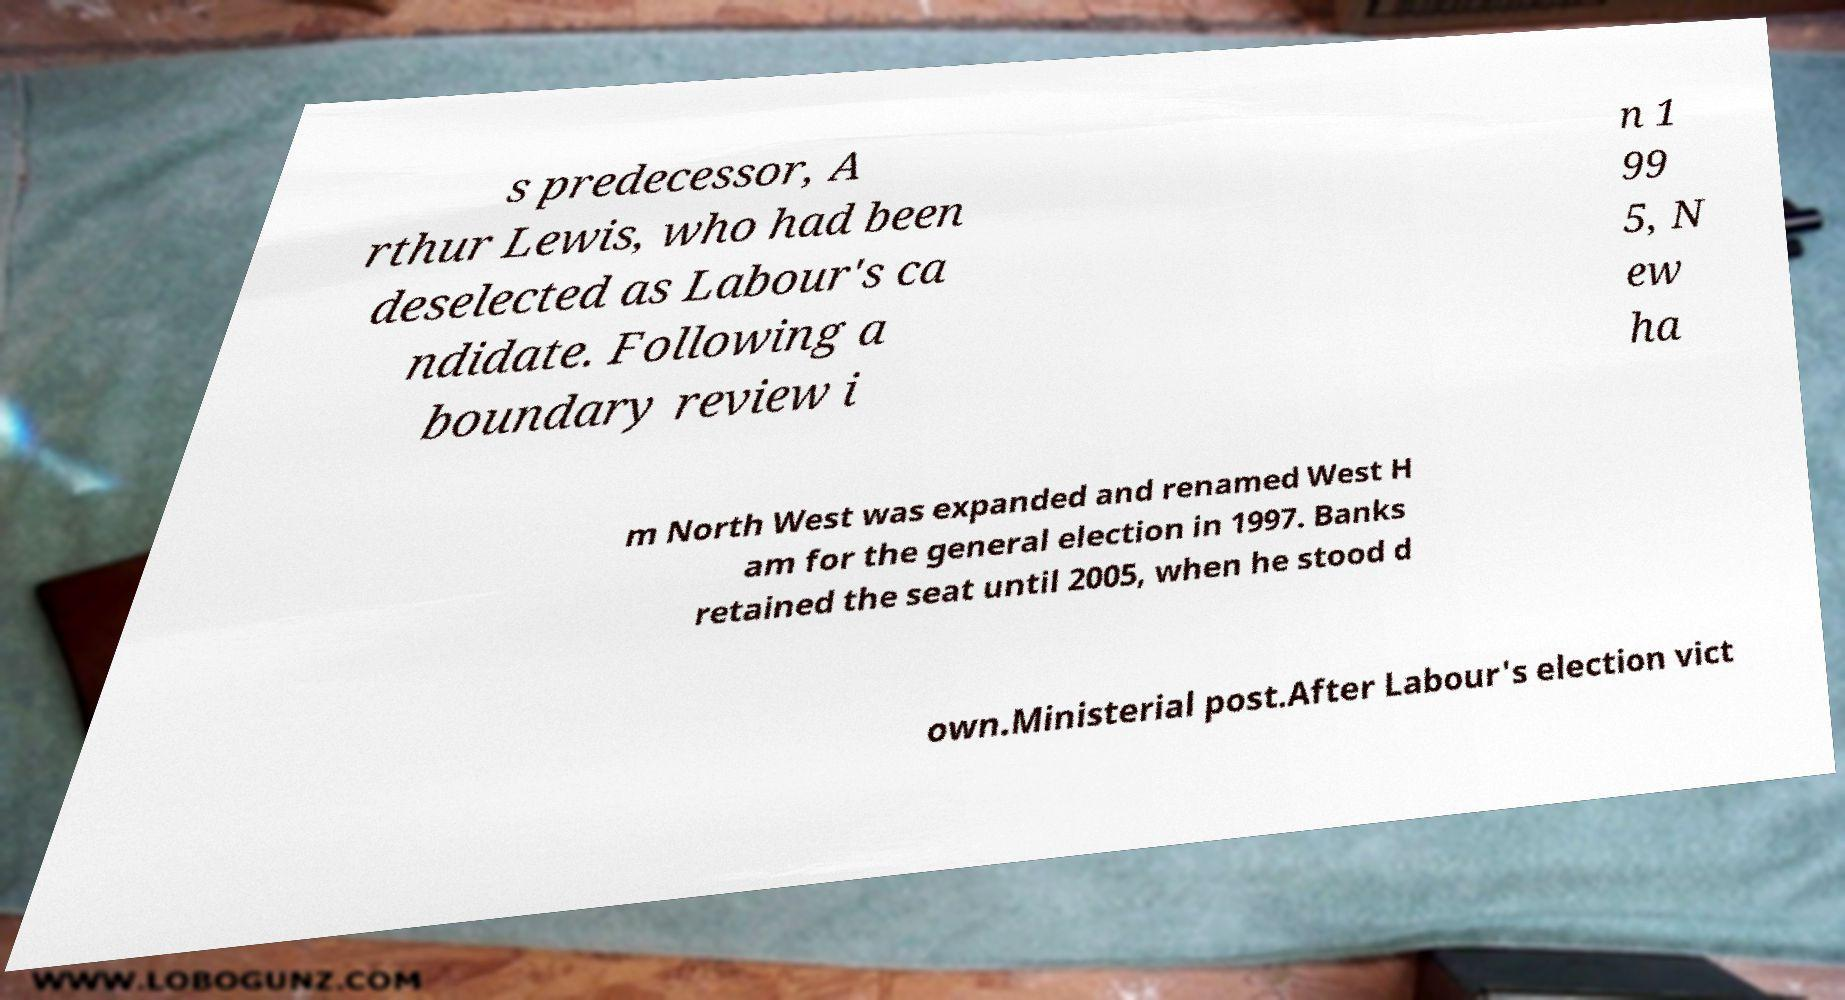I need the written content from this picture converted into text. Can you do that? s predecessor, A rthur Lewis, who had been deselected as Labour's ca ndidate. Following a boundary review i n 1 99 5, N ew ha m North West was expanded and renamed West H am for the general election in 1997. Banks retained the seat until 2005, when he stood d own.Ministerial post.After Labour's election vict 